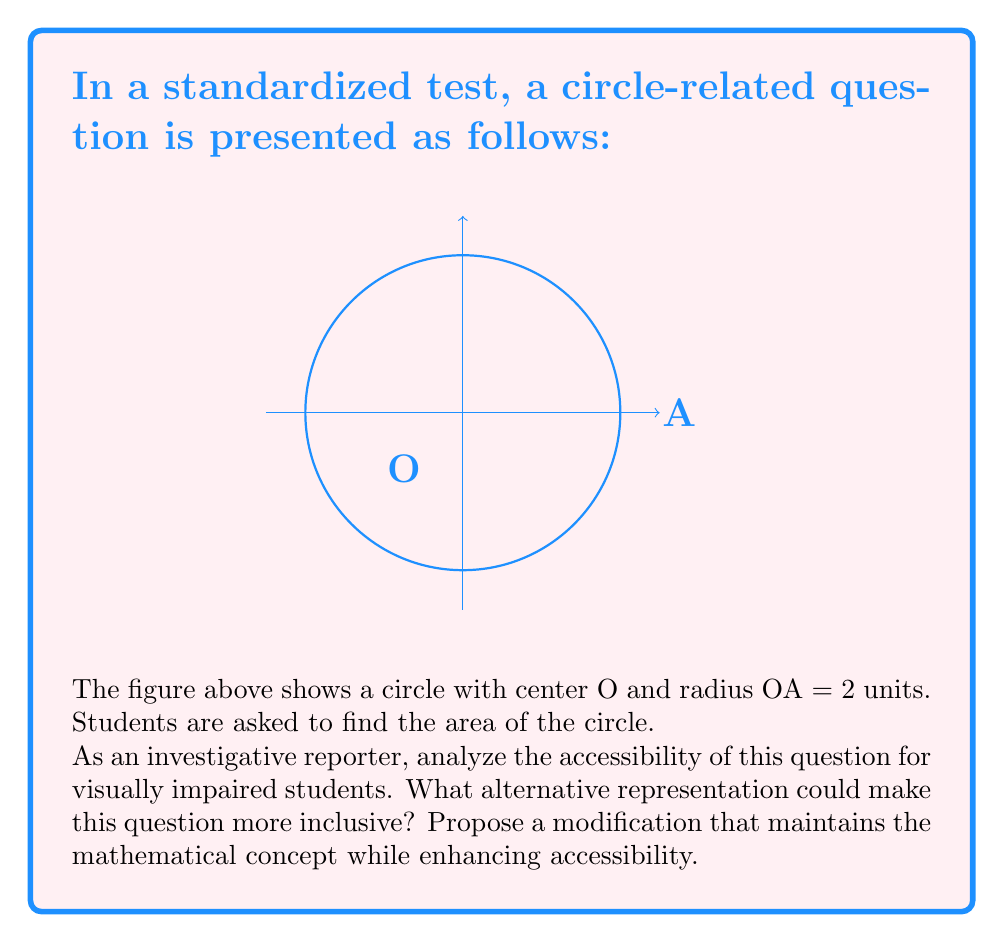Teach me how to tackle this problem. To analyze the accessibility of this question for visually impaired students and propose a more inclusive alternative, we need to consider the following steps:

1. Identify the barriers:
   - The question relies heavily on visual representation.
   - Important information (radius = 2 units) is only provided in the image.
   - The concept of area is presented in a visual context.

2. Consider alternative representations:
   - Textual description of the circle and its properties.
   - Tactile representation using raised line drawings or 3D models.
   - Audio description of the circle's properties.

3. Propose a modification:
   Let's reformulate the question to be more accessible:

   "A circle has a radius of 2 units. Calculate its area."

   This modification:
   - Removes the dependency on visual representation.
   - Directly provides the necessary information (radius) in the text.
   - Maintains the mathematical concept (calculating the area of a circle).

4. Solving the modified question:
   To find the area of a circle, we use the formula:
   
   $$ A = \pi r^2 $$
   
   Where $A$ is the area and $r$ is the radius.
   
   Substituting $r = 2$:
   
   $$ A = \pi (2)^2 = 4\pi $$

5. Accessibility enhancement:
   - This modified question can be easily converted to braille or read aloud.
   - It allows visually impaired students to focus on the mathematical concept rather than interpreting a visual diagram.
   - The solution process remains the same, ensuring equal challenge and assessment.

By making this change, we maintain the integrity of the mathematical assessment while significantly improving accessibility for visually impaired students.
Answer: Modified question: "A circle has a radius of 2 units. Calculate its area." Answer: $4\pi$ square units. 